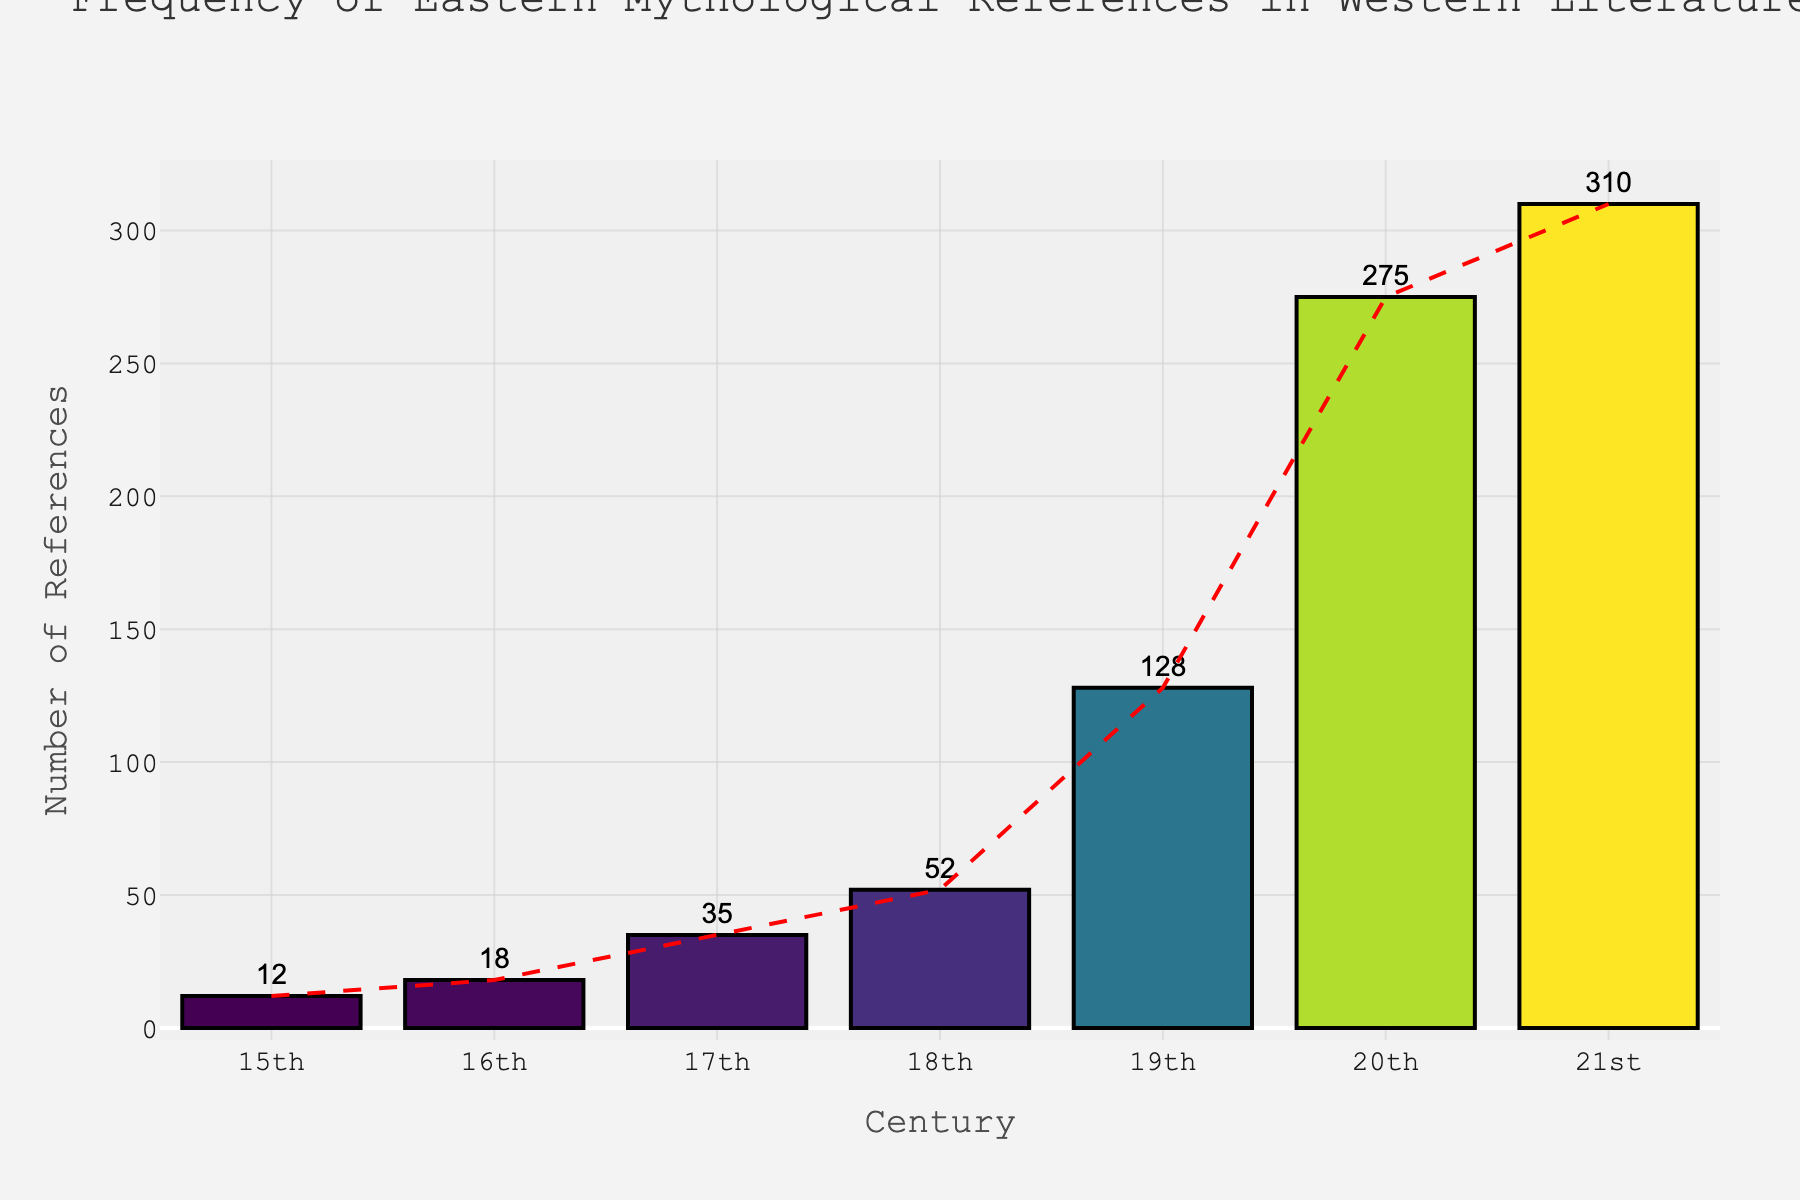Which century shows the highest frequency of Eastern mythological references? To determine the century with the highest frequency, look at the bar with the greatest height. The 21st century has the tallest bar, indicating the highest number of references at 310.
Answer: 21st century How many more references were there in the 19th century compared to the 16th century? Subtract the number of references in the 16th century from the number of references in the 19th century. The 19th century has 128 references and the 16th century has 18, so the difference is 128 - 18 = 110.
Answer: 110 What is the average number of references per century from the 15th to the 21st century? Add up all the references and divide by the number of centuries. Sum = 12 + 18 + 35 + 52 + 128 + 275 + 310 = 830. Number of centuries = 7. Average is 830 / 7 = 118.57
Answer: 118.57 Which century experienced the largest increase in references compared to the previous one? Calculate the differences between consecutive centuries: 
16th - 15th: 18 - 12 = 6 
17th - 16th: 35 - 18 = 17 
18th - 17th: 52 - 35 = 17 
19th - 18th: 128 - 52 = 76 
20th - 19th: 275 - 128 = 147 
21st - 20th: 310 - 275 = 35 
The largest increase is 147 between the 19th and 20th centuries.
Answer: 19th to 20th century During which centuries did the number of references double compared to the previous century? Compare the number of references to check if they doubled or more:
16th compared to 15th (18 vs 12): no
17th compared to 16th (35 vs 18): yes
18th compared to 17th (52 vs 35): no
19th compared to 18th (128 vs 52): yes
20th compared to 19th (275 vs 128): yes
21st compared to 20th (310 vs 275): no
Centuries with doubling are 17th, 19th, and 20th.
Answer: 17th, 19th, 20th What color is associated with the century that has the lowest number of references? The lowest number of references is in the 15th century. Looking at the Viridis colorscale, the 15th century bar appears in a lighter shade of the green to blue spectrum.
Answer: Light green Is the trend of Eastern mythological references mostly increasing, decreasing, or constant over the centuries? Observe the general direction of the trend line added to the graph. The line shows a clear overall increasing trend from the 15th to the 21st century.
Answer: Increasing By how much did the references increase from the 18th century to the 21st century? Subtract the number of references in the 18th century from the number in the 21st century. The references in the 21st century are 310, and in the 18th century are 52. The increase is 310 - 52 = 258.
Answer: 258 